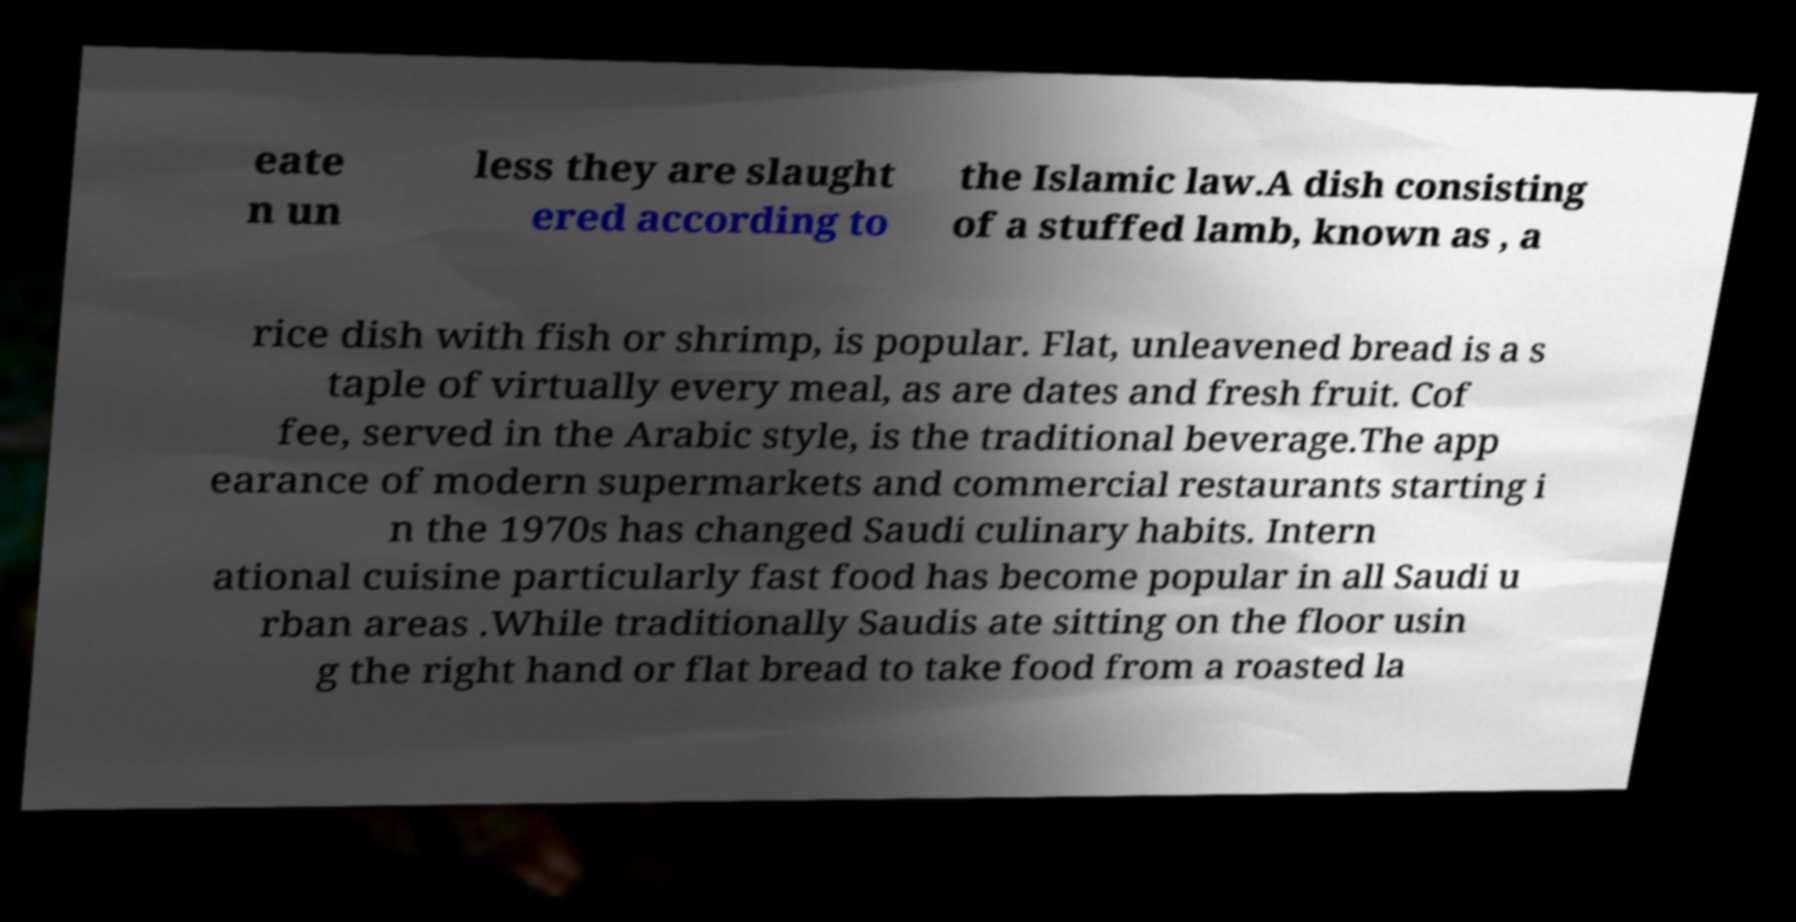Could you assist in decoding the text presented in this image and type it out clearly? eate n un less they are slaught ered according to the Islamic law.A dish consisting of a stuffed lamb, known as , a rice dish with fish or shrimp, is popular. Flat, unleavened bread is a s taple of virtually every meal, as are dates and fresh fruit. Cof fee, served in the Arabic style, is the traditional beverage.The app earance of modern supermarkets and commercial restaurants starting i n the 1970s has changed Saudi culinary habits. Intern ational cuisine particularly fast food has become popular in all Saudi u rban areas .While traditionally Saudis ate sitting on the floor usin g the right hand or flat bread to take food from a roasted la 